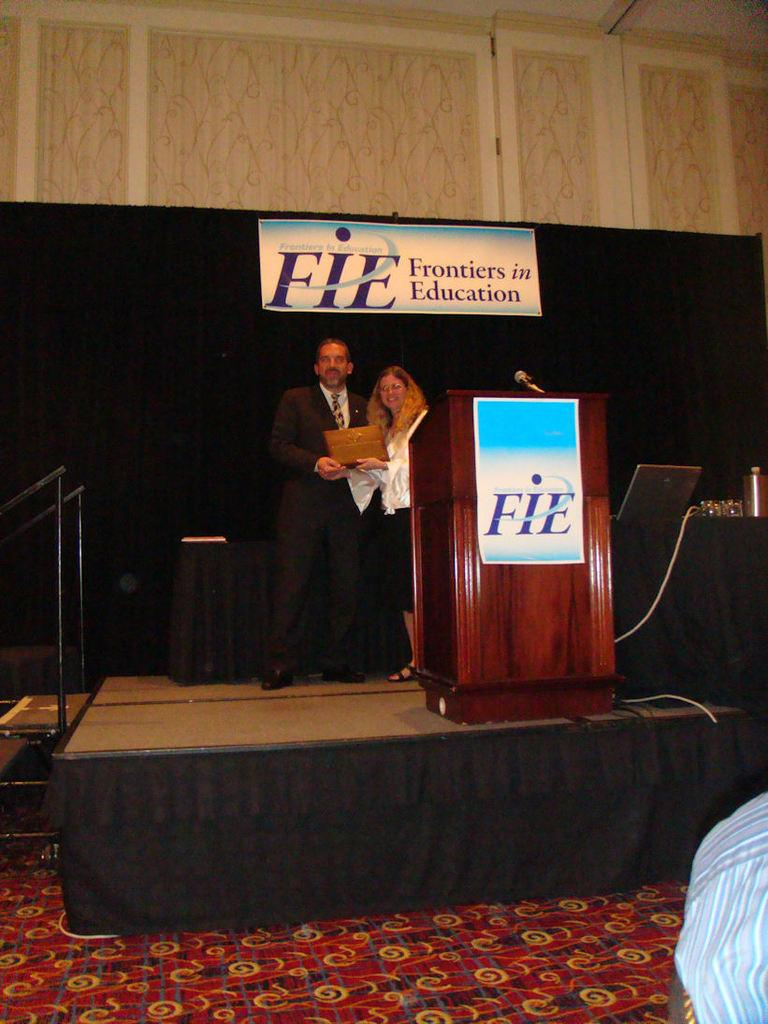What is the man in the image doing? The man is presenting an award in the image. Who is receiving the award from the man? The woman is receiving the award from the man. What can be seen on the table in the image? The table is covered with a black cover, and there is a laptop and a bottle present on the table. What type of knowledge is the loaf of bread representing in the image? There is no loaf of bread present in the image, so it cannot represent any type of knowledge. 